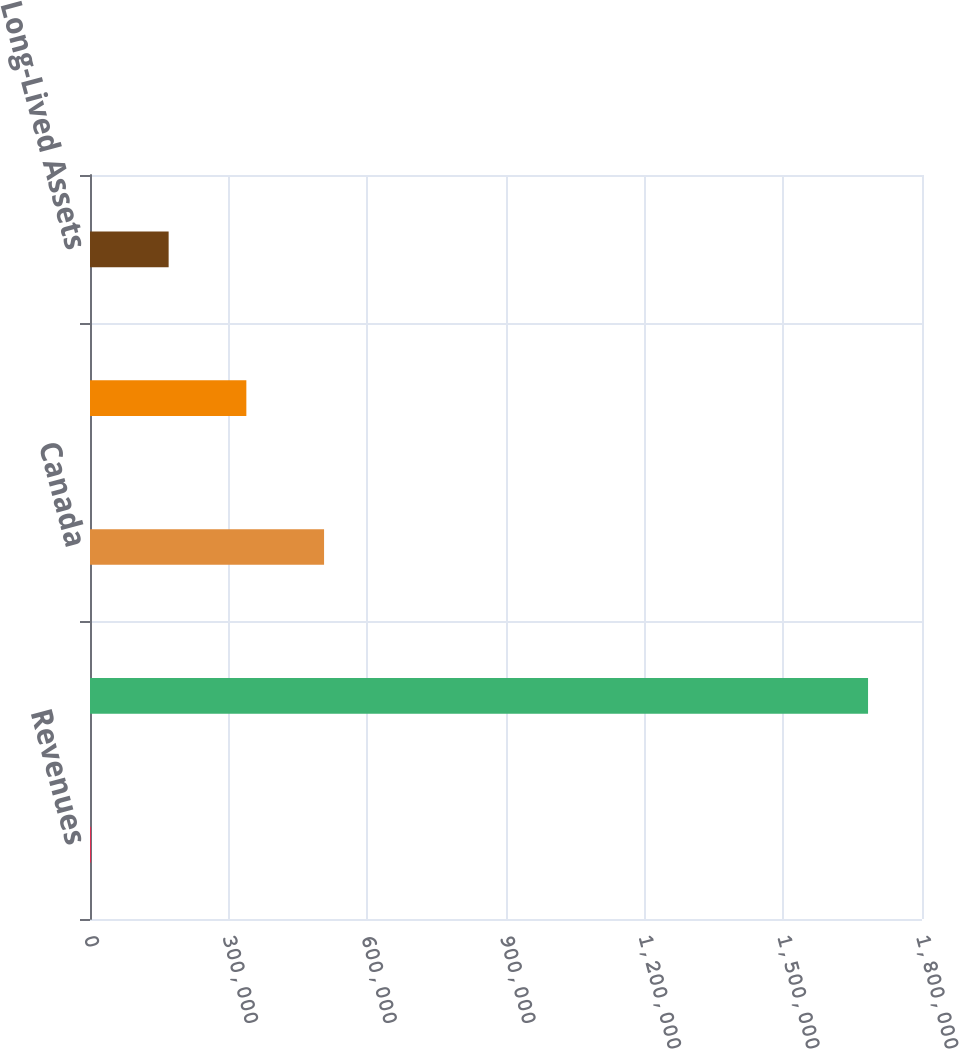Convert chart. <chart><loc_0><loc_0><loc_500><loc_500><bar_chart><fcel>Revenues<fcel>United States<fcel>Canada<fcel>Other foreign countries<fcel>Long-Lived Assets<nl><fcel>2006<fcel>1.68327e+06<fcel>506386<fcel>338259<fcel>170132<nl></chart> 